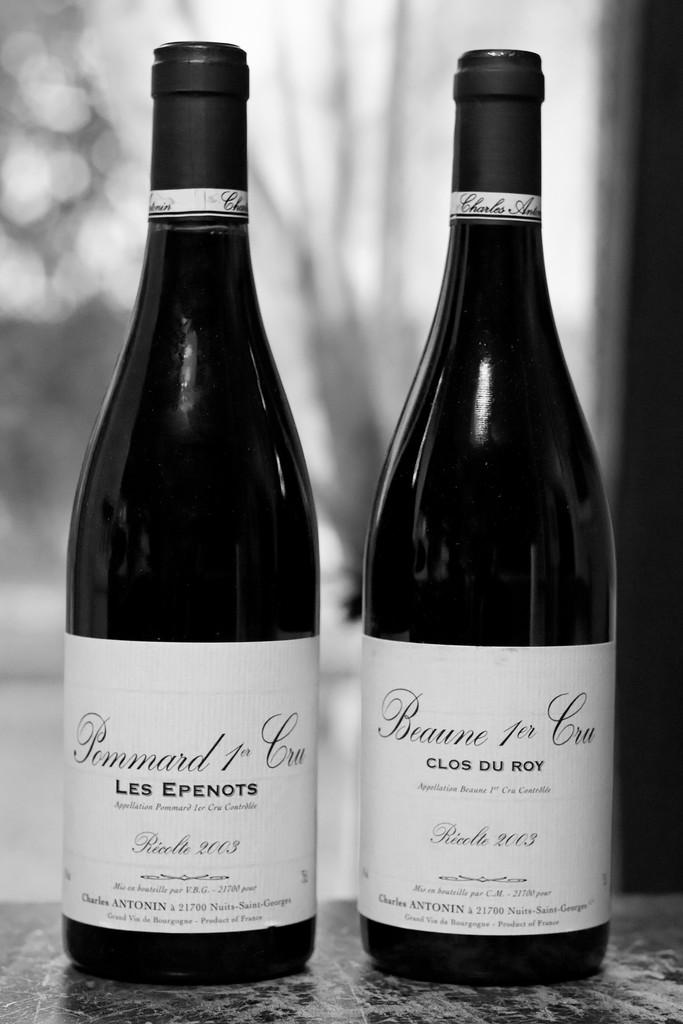<image>
Provide a brief description of the given image. Two bottles of wine by Pommard Cru sit side by side. 